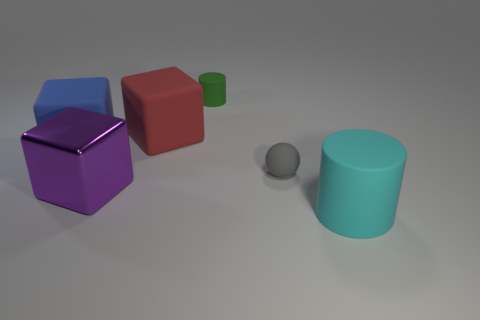What number of things are either tiny rubber things on the left side of the tiny matte sphere or green matte cylinders to the right of the purple thing?
Make the answer very short. 1. Do the small object that is in front of the small green cylinder and the metallic object have the same color?
Ensure brevity in your answer.  No. What number of metallic things are either big blocks or cylinders?
Your response must be concise. 1. What shape is the big cyan object?
Provide a short and direct response. Cylinder. Is there anything else that has the same material as the cyan cylinder?
Offer a very short reply. Yes. Are the large purple object and the big red thing made of the same material?
Provide a short and direct response. No. Are there any matte things on the left side of the small rubber object that is to the right of the rubber cylinder on the left side of the big cyan thing?
Your answer should be compact. Yes. What number of other objects are there of the same shape as the gray object?
Make the answer very short. 0. The large thing that is on the right side of the shiny cube and in front of the blue matte cube has what shape?
Keep it short and to the point. Cylinder. What is the color of the tiny thing that is in front of the cylinder that is to the left of the matte cylinder that is in front of the green object?
Keep it short and to the point. Gray. 